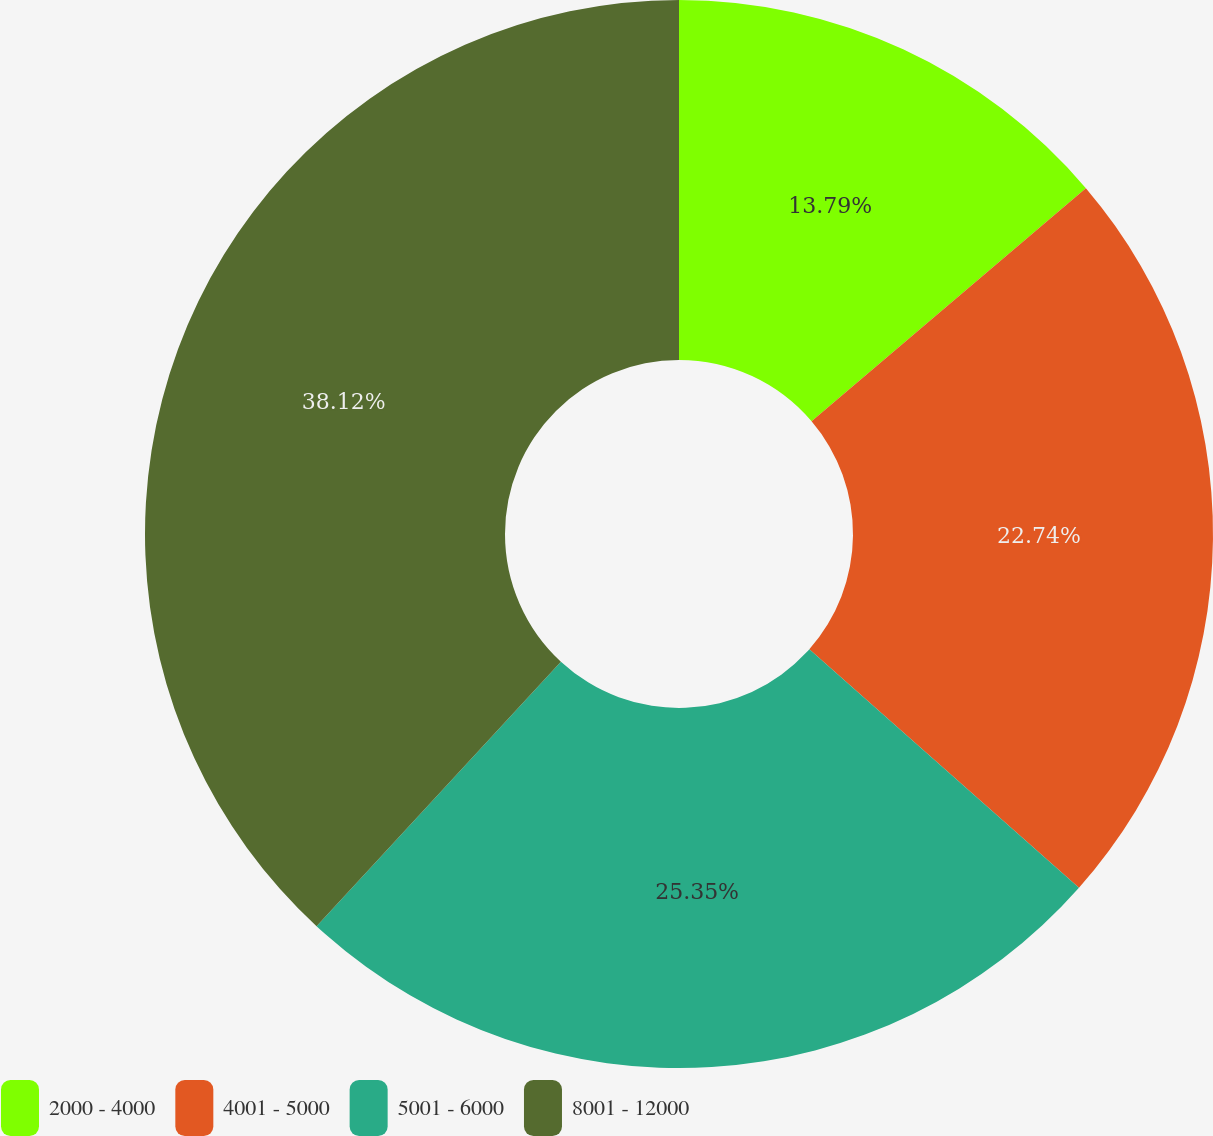Convert chart. <chart><loc_0><loc_0><loc_500><loc_500><pie_chart><fcel>2000 - 4000<fcel>4001 - 5000<fcel>5001 - 6000<fcel>8001 - 12000<nl><fcel>13.79%<fcel>22.74%<fcel>25.35%<fcel>38.13%<nl></chart> 